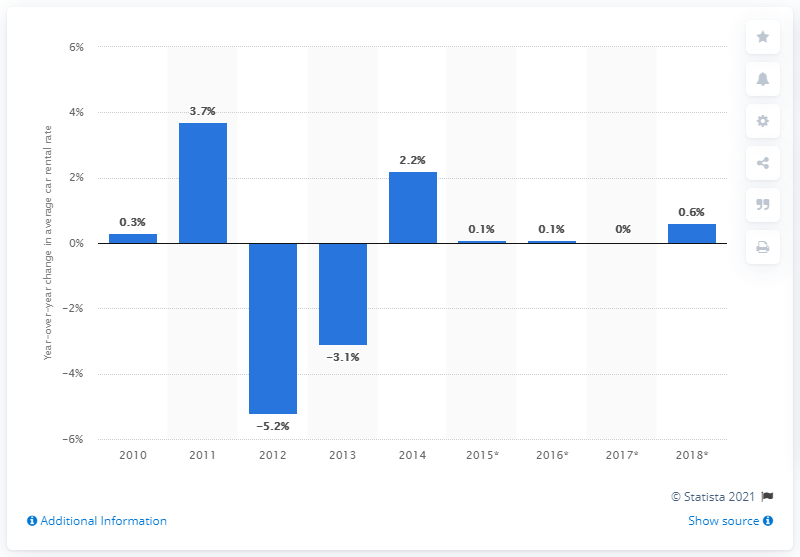List a handful of essential elements in this visual. The average global car rental rate increased by 2.2% in 2014, according to a recent analysis. The forecast predicted that global car rental rates would increase by 0.6% in 2018. 